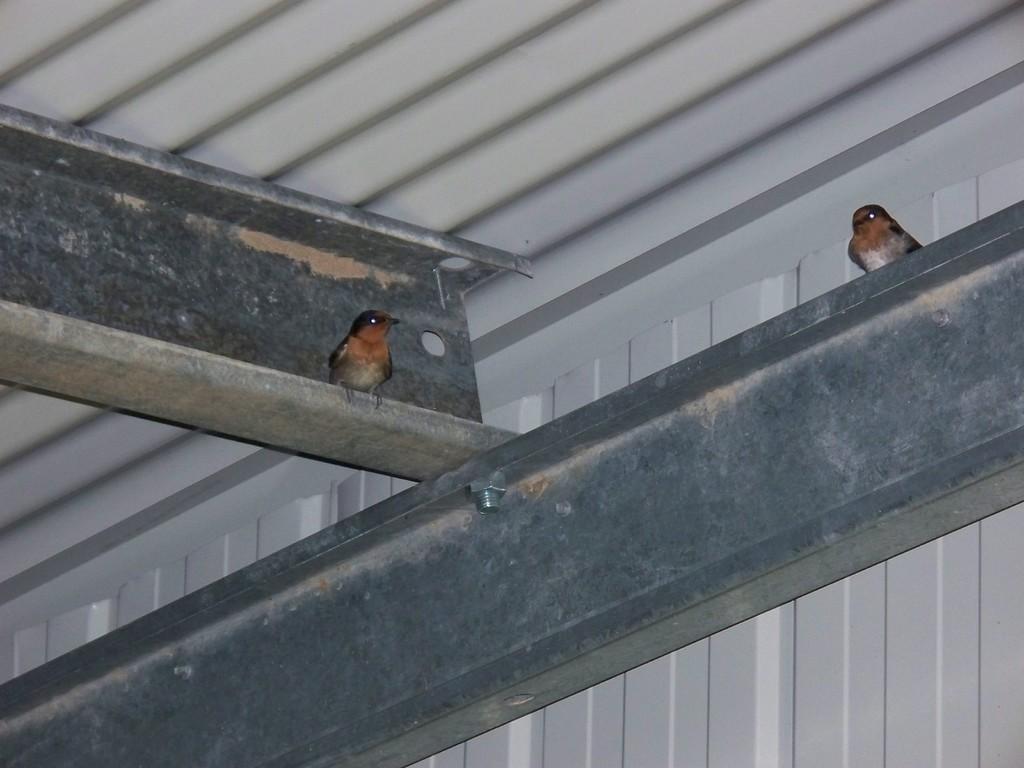Can you describe this image briefly? In this given picture, I can see two iron metal rods and a shed, Towards right i can see a bird standing on a iron rod, towards left we can see a another bird standing on a rod. 